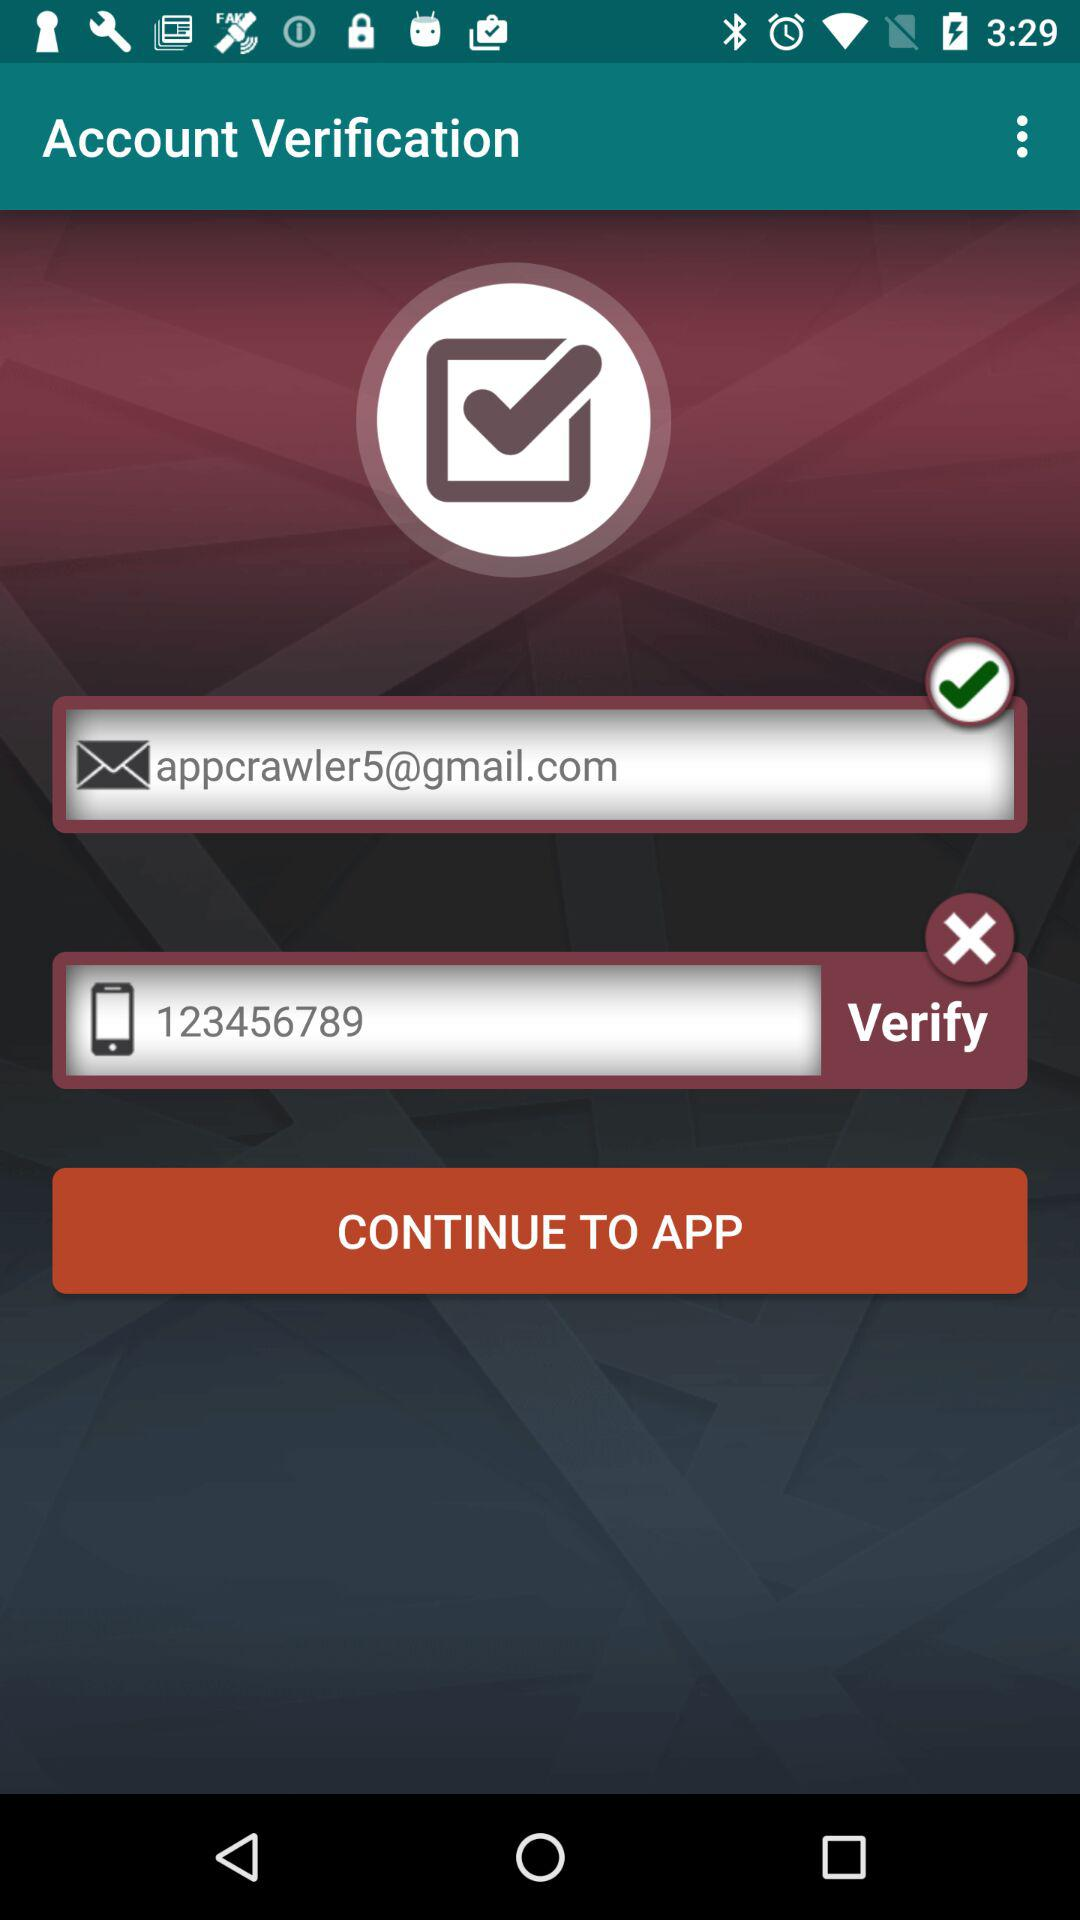What's the mobile number? The mobile number is 123456789. 